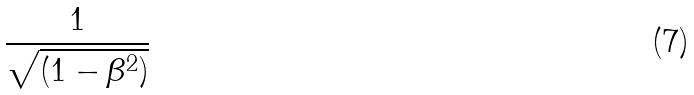<formula> <loc_0><loc_0><loc_500><loc_500>\frac { 1 } { \sqrt { ( 1 - \beta ^ { 2 } ) } }</formula> 